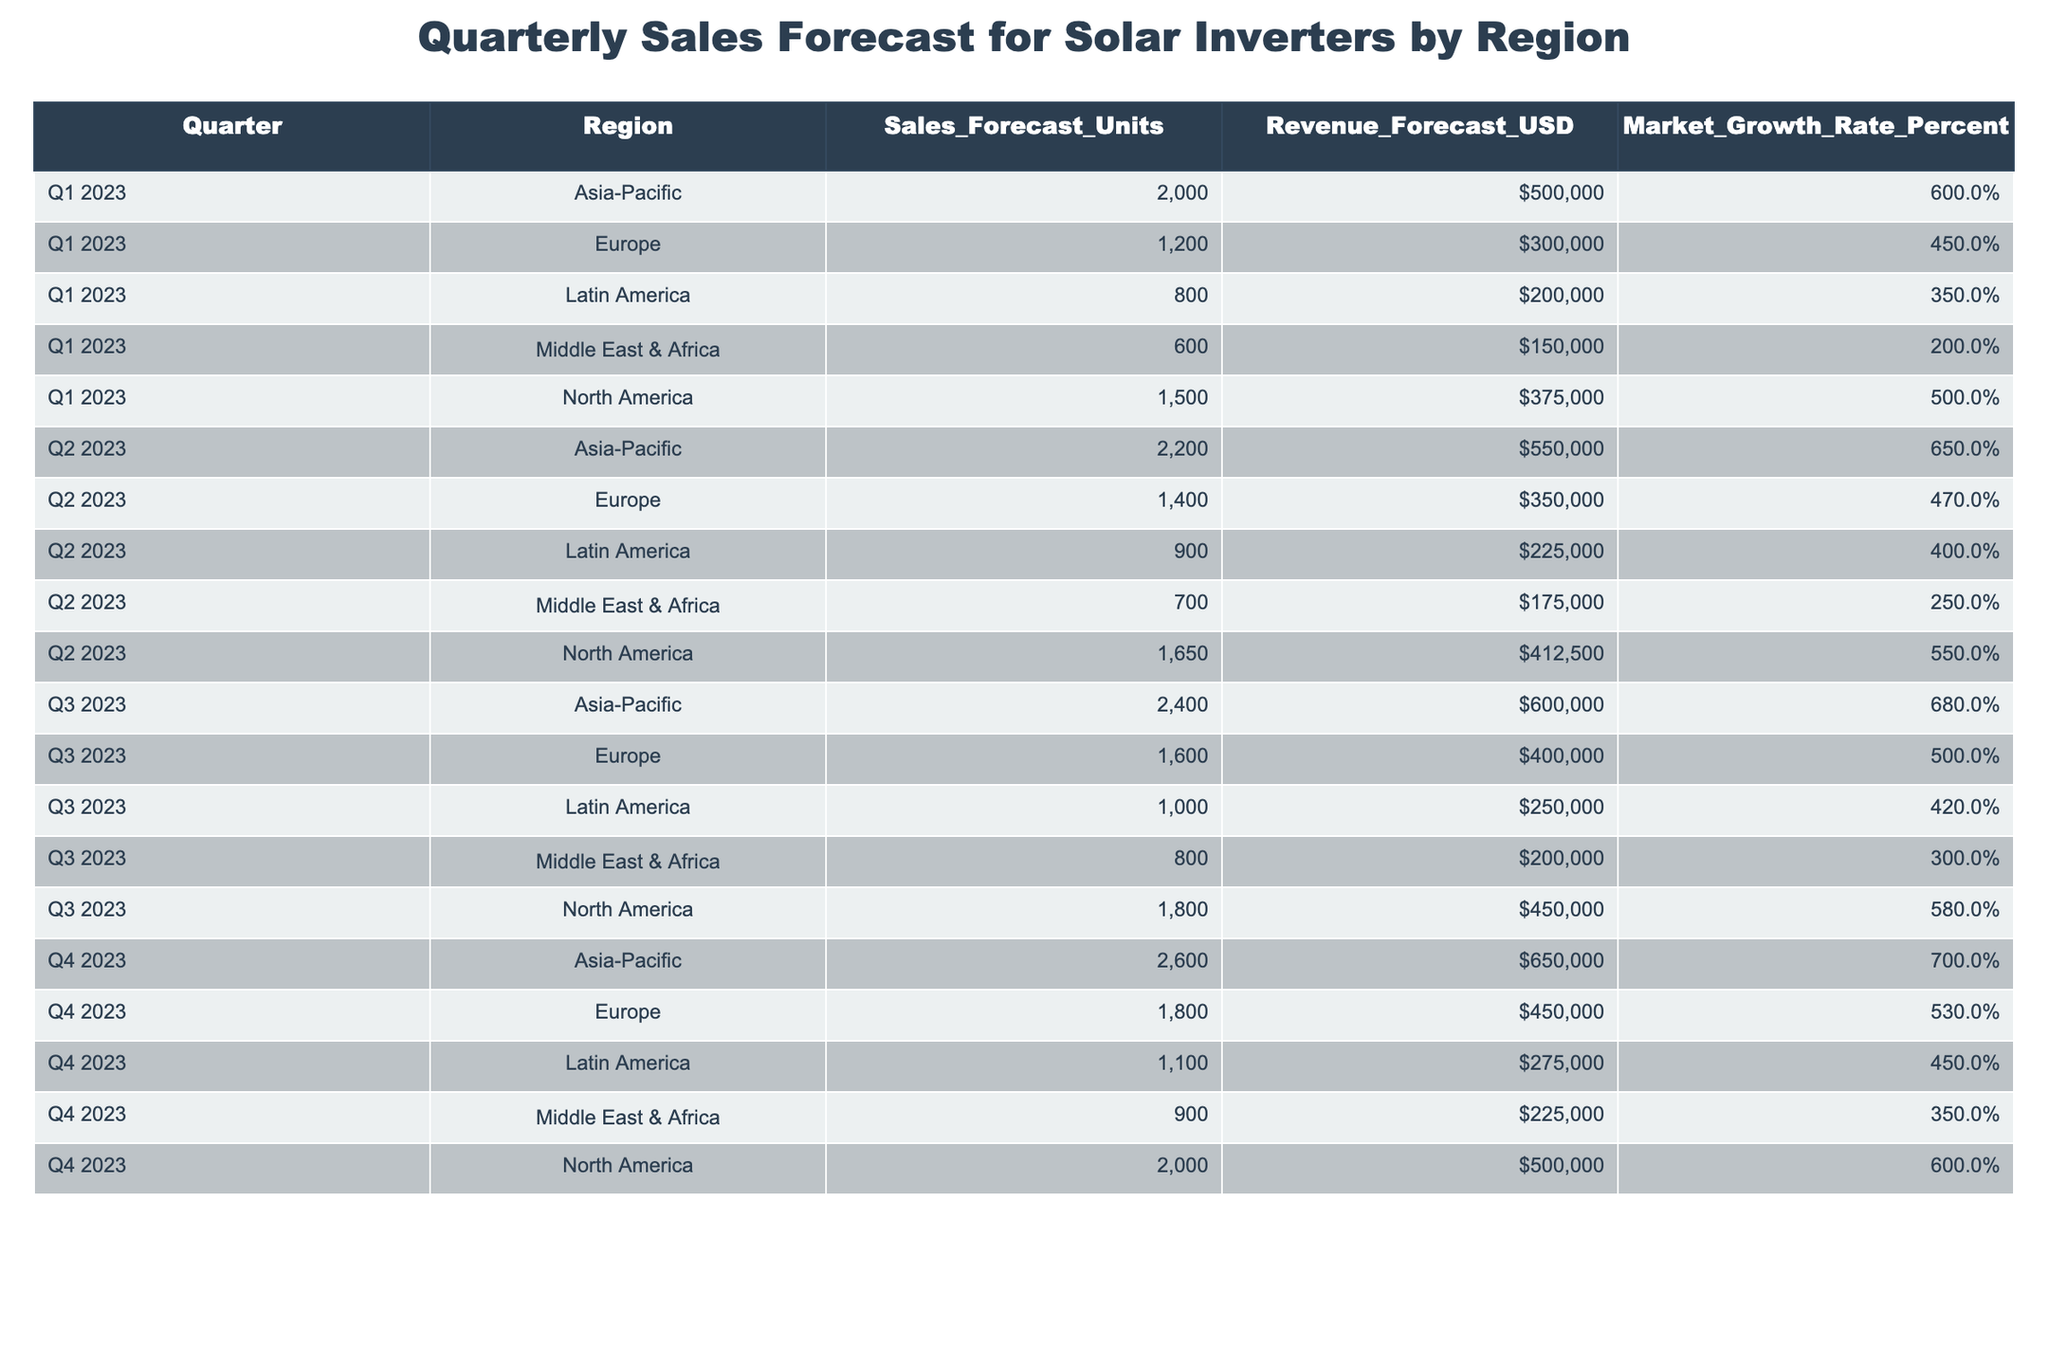What is the total sales forecast for Latin America in Q3 2023? The sales forecast for Latin America in Q3 2023 is given directly in the table as 1000 units.
Answer: 1000 What was the revenue forecast for Asia-Pacific in Q1 2023? The revenue forecast for Asia-Pacific in Q1 2023 is listed as 500000 USD.
Answer: 500000 USD Which region had the highest sales forecast in Q4 2023? By checking the Q4 2023 figures, Asia-Pacific has the highest sales forecast at 2600 units while others are lower.
Answer: Asia-Pacific What is the average market growth rate for Europe across all quarters? The market growth rates for Europe in each quarter are 4.5, 4.7, 5.0, and 5.3. Calculating the average: (4.5 + 4.7 + 5.0 + 5.3) / 4 = 4.625.
Answer: 4.625 Is the sales forecast for North America higher in Q2 2023 than in Q1 2023? The sales forecast for North America in Q2 2023 is 1650 units, which is higher than the Q1 2023 forecast of 1500 units.
Answer: Yes Which region experienced the highest market growth rate in Q3 2023? Looking at the Q3 2023 growth rates, Asia-Pacific had the highest market growth rate of 6.8%.
Answer: Asia-Pacific What is the difference in revenue forecast between Asia-Pacific and Europe in Q4 2023? The revenue forecast for Asia-Pacific in Q4 2023 is 650000 USD and for Europe, it is 450000 USD. The difference is 650000 - 450000 = 200000 USD.
Answer: 200000 USD Are the total sales forecasts for the Middle East & Africa across all quarters greater than that for Latin America? The totals for Middle East & Africa are 600 + 700 + 800 + 900 = 3000 units. For Latin America, totals are 800 + 900 + 1000 + 1100 = 3800 units. Since 3000 is less than 3800, the statement is false.
Answer: No What is the total revenue forecast for North America across all quarters? The revenue forecasts for North America are 375000, 412500, 450000, and 500000. Adding them results in 375000 + 412500 + 450000 + 500000 = 1732500 USD.
Answer: 1732500 USD 